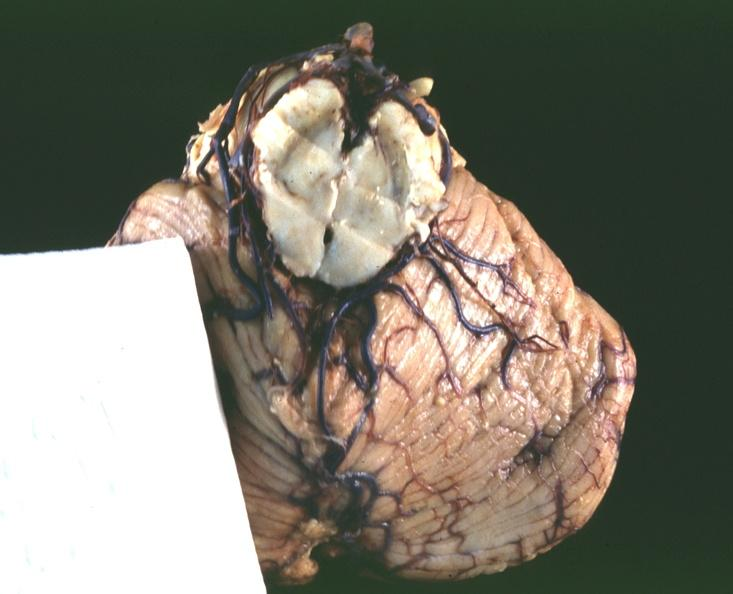s spinal column present?
Answer the question using a single word or phrase. No 